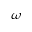Convert formula to latex. <formula><loc_0><loc_0><loc_500><loc_500>\omega</formula> 